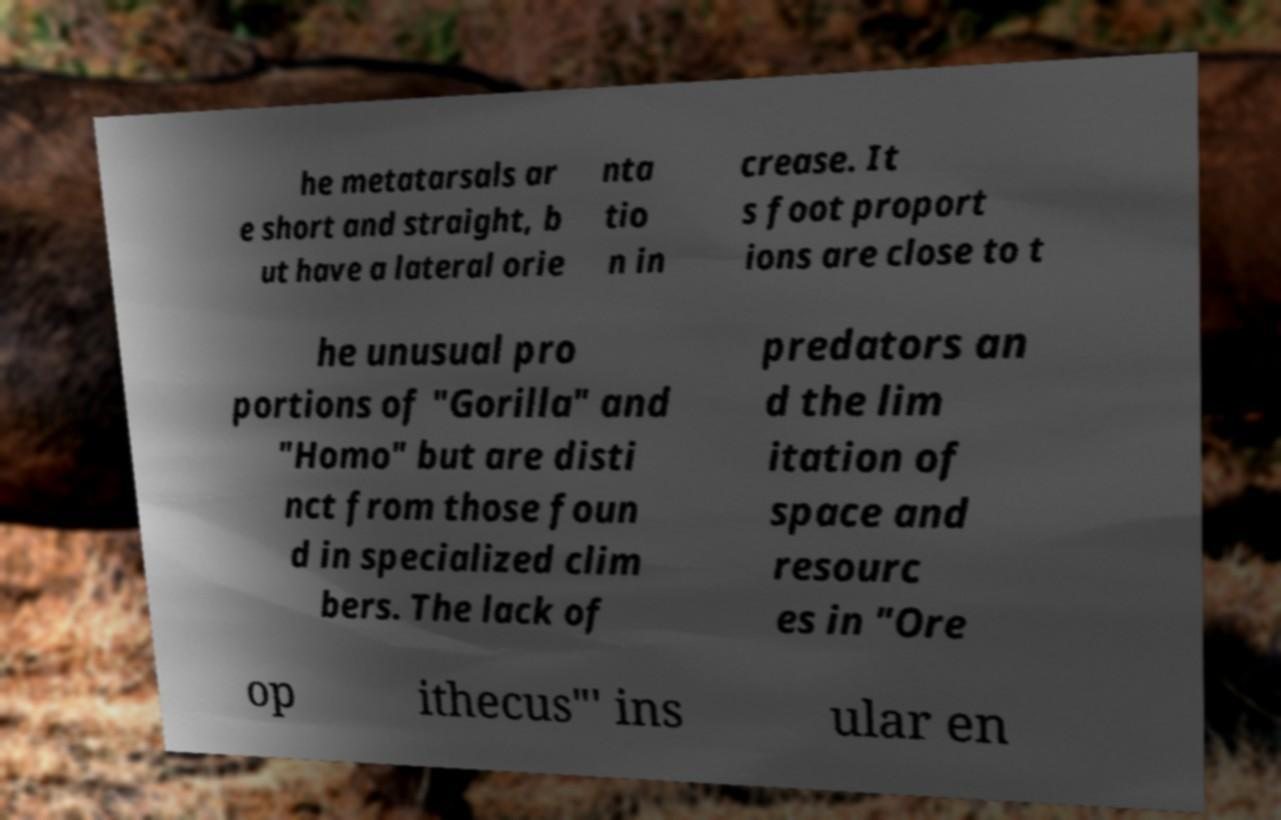Can you accurately transcribe the text from the provided image for me? he metatarsals ar e short and straight, b ut have a lateral orie nta tio n in crease. It s foot proport ions are close to t he unusual pro portions of "Gorilla" and "Homo" but are disti nct from those foun d in specialized clim bers. The lack of predators an d the lim itation of space and resourc es in "Ore op ithecus"′ ins ular en 